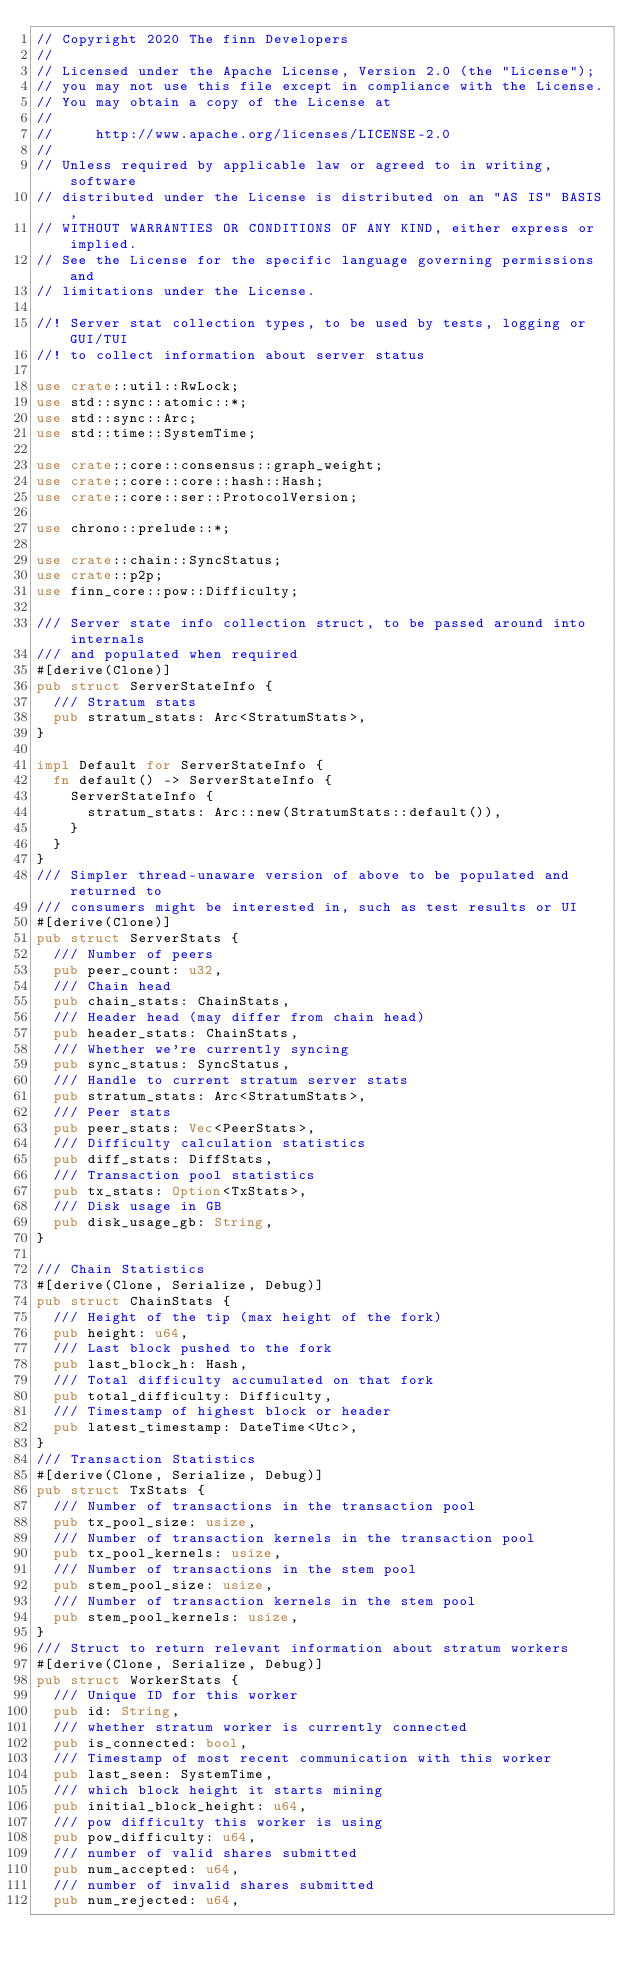Convert code to text. <code><loc_0><loc_0><loc_500><loc_500><_Rust_>// Copyright 2020 The finn Developers
//
// Licensed under the Apache License, Version 2.0 (the "License");
// you may not use this file except in compliance with the License.
// You may obtain a copy of the License at
//
//     http://www.apache.org/licenses/LICENSE-2.0
//
// Unless required by applicable law or agreed to in writing, software
// distributed under the License is distributed on an "AS IS" BASIS,
// WITHOUT WARRANTIES OR CONDITIONS OF ANY KIND, either express or implied.
// See the License for the specific language governing permissions and
// limitations under the License.

//! Server stat collection types, to be used by tests, logging or GUI/TUI
//! to collect information about server status

use crate::util::RwLock;
use std::sync::atomic::*;
use std::sync::Arc;
use std::time::SystemTime;

use crate::core::consensus::graph_weight;
use crate::core::core::hash::Hash;
use crate::core::ser::ProtocolVersion;

use chrono::prelude::*;

use crate::chain::SyncStatus;
use crate::p2p;
use finn_core::pow::Difficulty;

/// Server state info collection struct, to be passed around into internals
/// and populated when required
#[derive(Clone)]
pub struct ServerStateInfo {
	/// Stratum stats
	pub stratum_stats: Arc<StratumStats>,
}

impl Default for ServerStateInfo {
	fn default() -> ServerStateInfo {
		ServerStateInfo {
			stratum_stats: Arc::new(StratumStats::default()),
		}
	}
}
/// Simpler thread-unaware version of above to be populated and returned to
/// consumers might be interested in, such as test results or UI
#[derive(Clone)]
pub struct ServerStats {
	/// Number of peers
	pub peer_count: u32,
	/// Chain head
	pub chain_stats: ChainStats,
	/// Header head (may differ from chain head)
	pub header_stats: ChainStats,
	/// Whether we're currently syncing
	pub sync_status: SyncStatus,
	/// Handle to current stratum server stats
	pub stratum_stats: Arc<StratumStats>,
	/// Peer stats
	pub peer_stats: Vec<PeerStats>,
	/// Difficulty calculation statistics
	pub diff_stats: DiffStats,
	/// Transaction pool statistics
	pub tx_stats: Option<TxStats>,
	/// Disk usage in GB
	pub disk_usage_gb: String,
}

/// Chain Statistics
#[derive(Clone, Serialize, Debug)]
pub struct ChainStats {
	/// Height of the tip (max height of the fork)
	pub height: u64,
	/// Last block pushed to the fork
	pub last_block_h: Hash,
	/// Total difficulty accumulated on that fork
	pub total_difficulty: Difficulty,
	/// Timestamp of highest block or header
	pub latest_timestamp: DateTime<Utc>,
}
/// Transaction Statistics
#[derive(Clone, Serialize, Debug)]
pub struct TxStats {
	/// Number of transactions in the transaction pool
	pub tx_pool_size: usize,
	/// Number of transaction kernels in the transaction pool
	pub tx_pool_kernels: usize,
	/// Number of transactions in the stem pool
	pub stem_pool_size: usize,
	/// Number of transaction kernels in the stem pool
	pub stem_pool_kernels: usize,
}
/// Struct to return relevant information about stratum workers
#[derive(Clone, Serialize, Debug)]
pub struct WorkerStats {
	/// Unique ID for this worker
	pub id: String,
	/// whether stratum worker is currently connected
	pub is_connected: bool,
	/// Timestamp of most recent communication with this worker
	pub last_seen: SystemTime,
	/// which block height it starts mining
	pub initial_block_height: u64,
	/// pow difficulty this worker is using
	pub pow_difficulty: u64,
	/// number of valid shares submitted
	pub num_accepted: u64,
	/// number of invalid shares submitted
	pub num_rejected: u64,</code> 